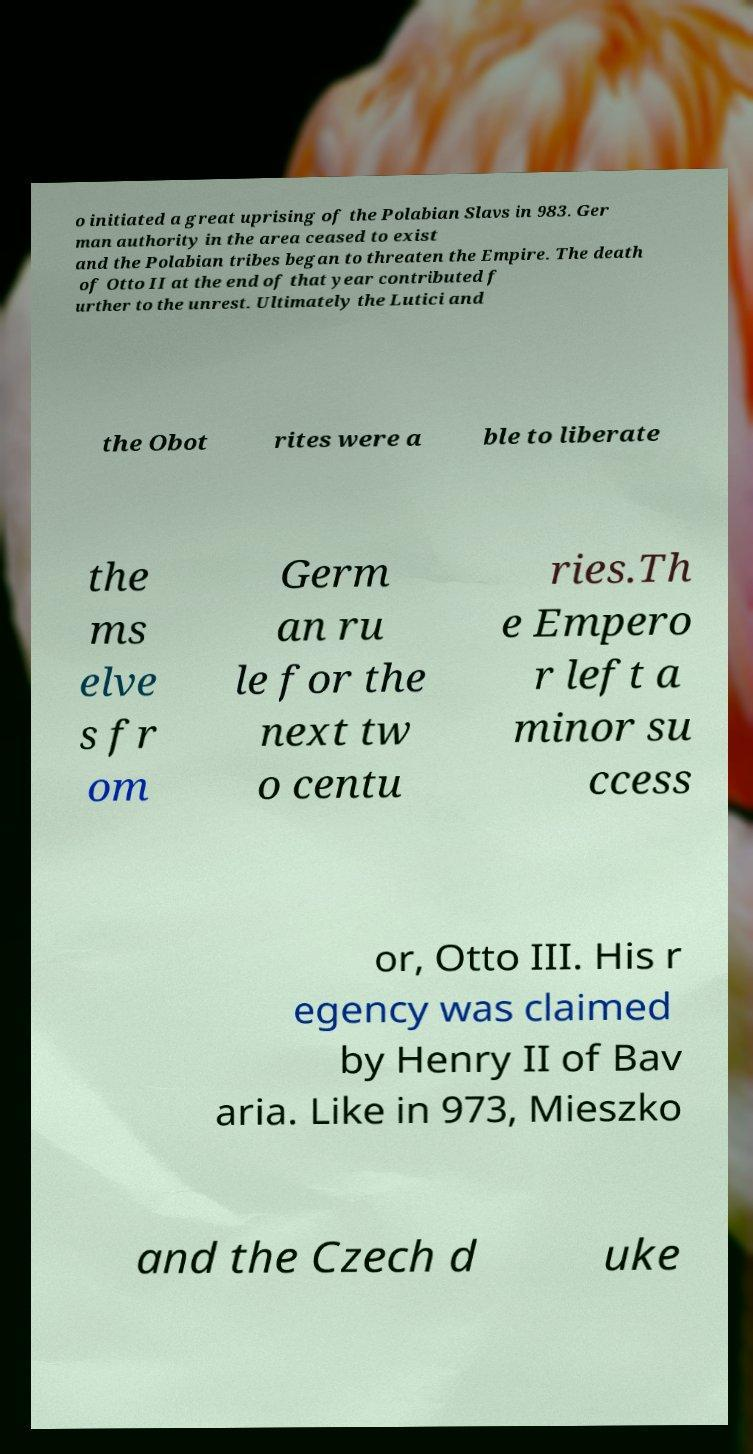Could you extract and type out the text from this image? o initiated a great uprising of the Polabian Slavs in 983. Ger man authority in the area ceased to exist and the Polabian tribes began to threaten the Empire. The death of Otto II at the end of that year contributed f urther to the unrest. Ultimately the Lutici and the Obot rites were a ble to liberate the ms elve s fr om Germ an ru le for the next tw o centu ries.Th e Empero r left a minor su ccess or, Otto III. His r egency was claimed by Henry II of Bav aria. Like in 973, Mieszko and the Czech d uke 